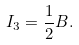<formula> <loc_0><loc_0><loc_500><loc_500>I _ { 3 } = \frac { 1 } { 2 } B .</formula> 